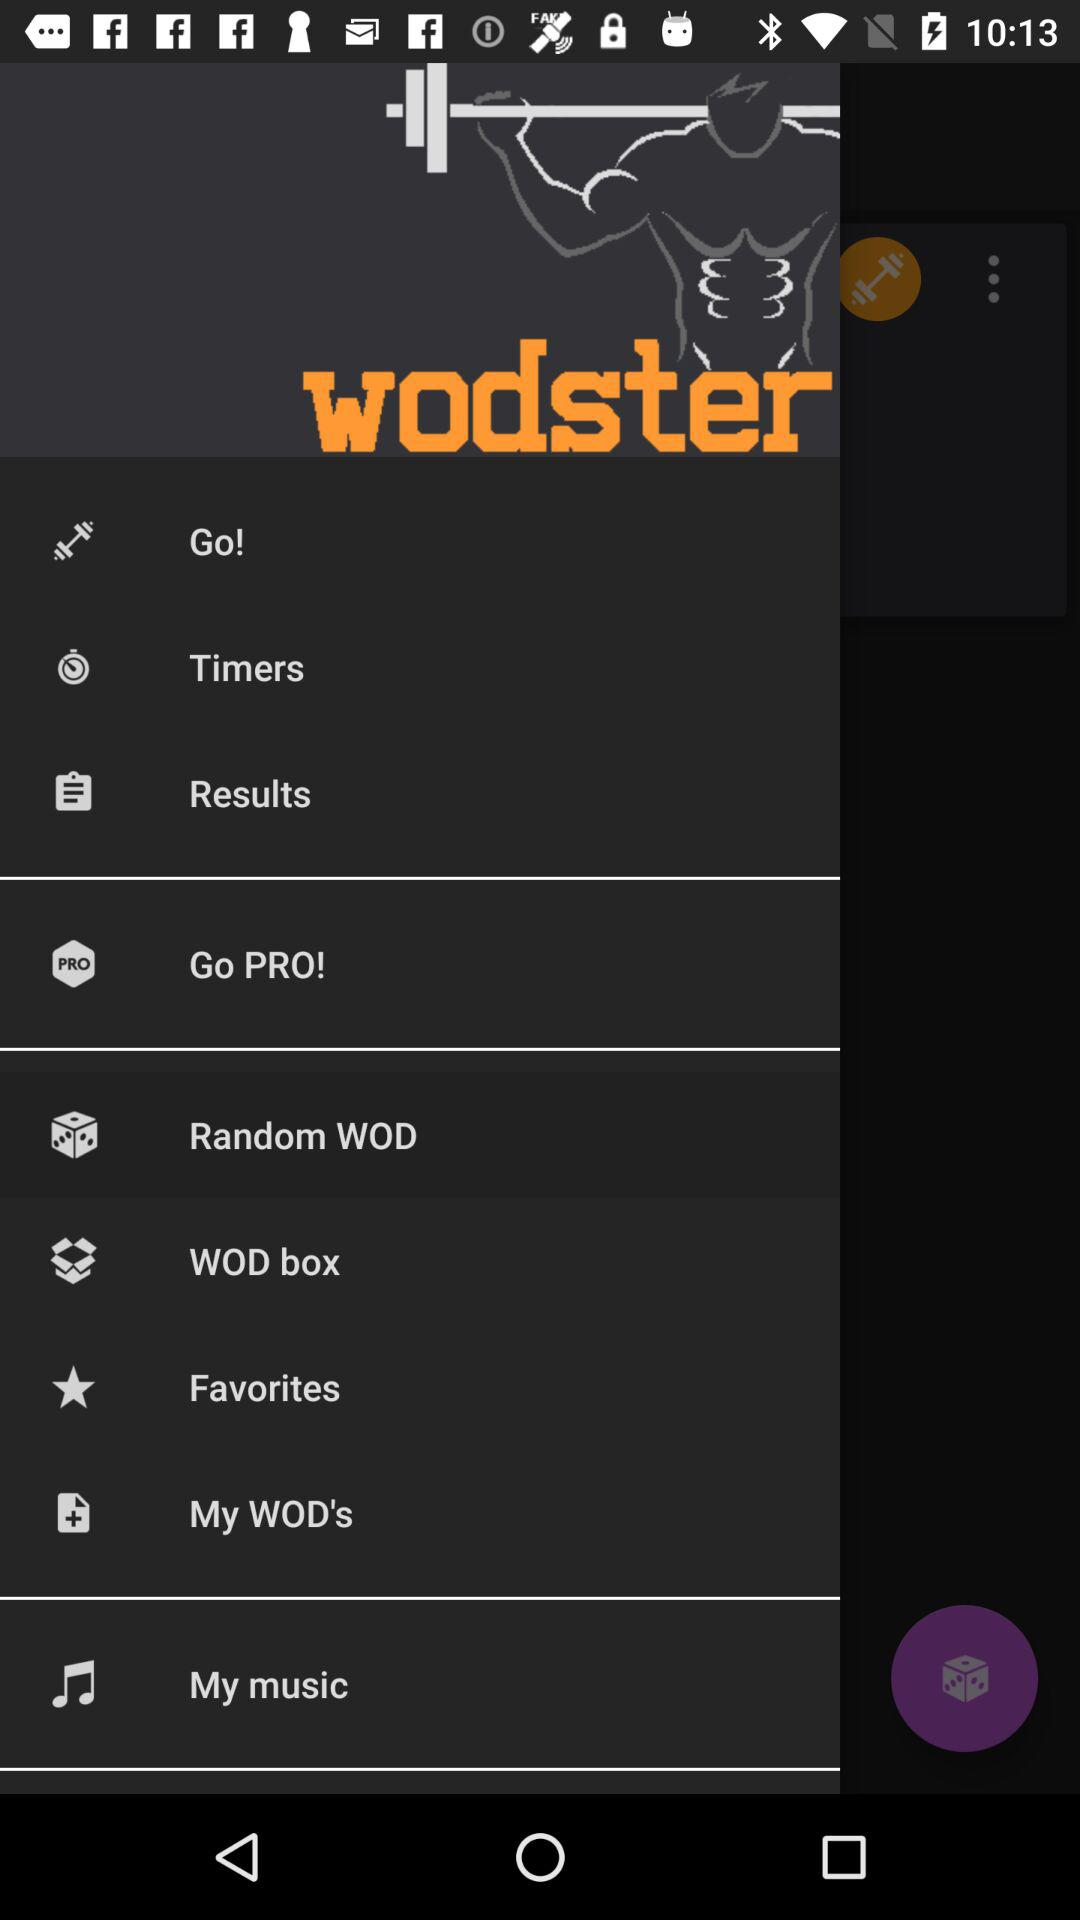What is the name of the application? The name of the application is "wodster". 